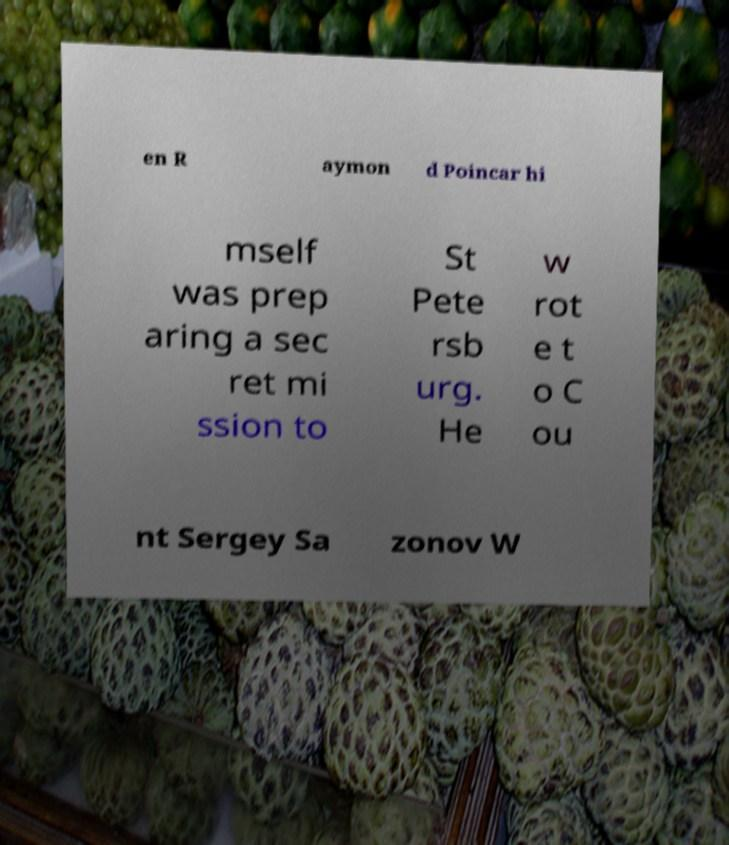There's text embedded in this image that I need extracted. Can you transcribe it verbatim? en R aymon d Poincar hi mself was prep aring a sec ret mi ssion to St Pete rsb urg. He w rot e t o C ou nt Sergey Sa zonov W 